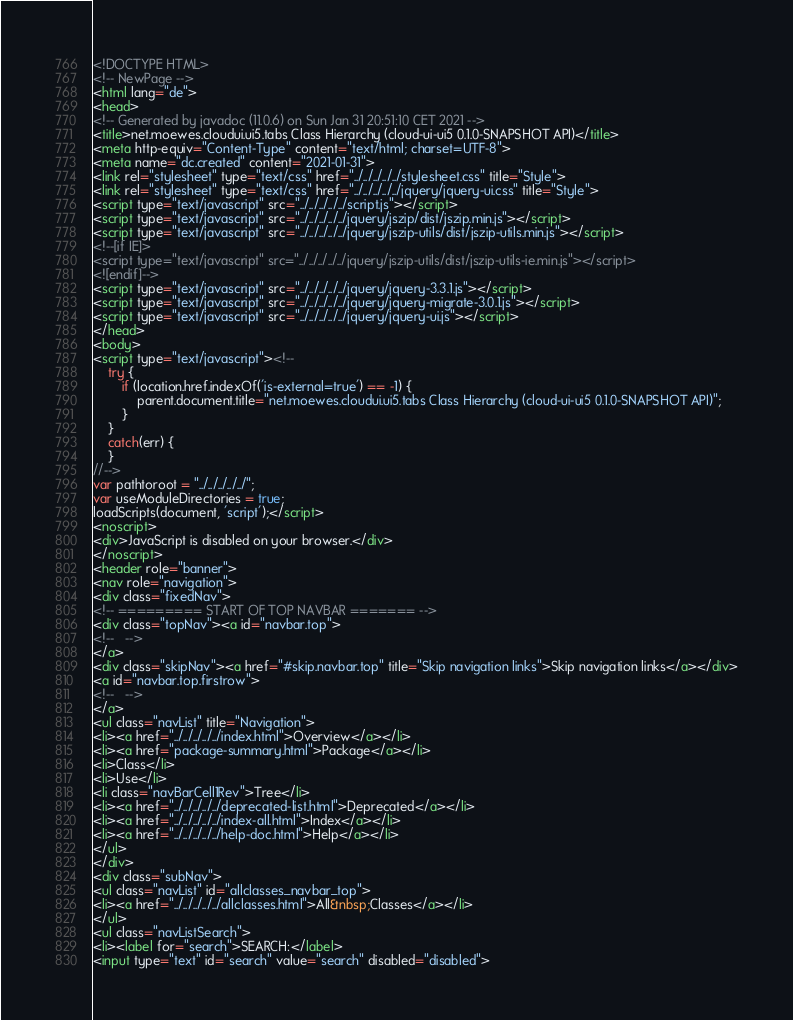<code> <loc_0><loc_0><loc_500><loc_500><_HTML_><!DOCTYPE HTML>
<!-- NewPage -->
<html lang="de">
<head>
<!-- Generated by javadoc (11.0.6) on Sun Jan 31 20:51:10 CET 2021 -->
<title>net.moewes.cloudui.ui5.tabs Class Hierarchy (cloud-ui-ui5 0.1.0-SNAPSHOT API)</title>
<meta http-equiv="Content-Type" content="text/html; charset=UTF-8">
<meta name="dc.created" content="2021-01-31">
<link rel="stylesheet" type="text/css" href="../../../../../stylesheet.css" title="Style">
<link rel="stylesheet" type="text/css" href="../../../../../jquery/jquery-ui.css" title="Style">
<script type="text/javascript" src="../../../../../script.js"></script>
<script type="text/javascript" src="../../../../../jquery/jszip/dist/jszip.min.js"></script>
<script type="text/javascript" src="../../../../../jquery/jszip-utils/dist/jszip-utils.min.js"></script>
<!--[if IE]>
<script type="text/javascript" src="../../../../../jquery/jszip-utils/dist/jszip-utils-ie.min.js"></script>
<![endif]-->
<script type="text/javascript" src="../../../../../jquery/jquery-3.3.1.js"></script>
<script type="text/javascript" src="../../../../../jquery/jquery-migrate-3.0.1.js"></script>
<script type="text/javascript" src="../../../../../jquery/jquery-ui.js"></script>
</head>
<body>
<script type="text/javascript"><!--
    try {
        if (location.href.indexOf('is-external=true') == -1) {
            parent.document.title="net.moewes.cloudui.ui5.tabs Class Hierarchy (cloud-ui-ui5 0.1.0-SNAPSHOT API)";
        }
    }
    catch(err) {
    }
//-->
var pathtoroot = "../../../../../";
var useModuleDirectories = true;
loadScripts(document, 'script');</script>
<noscript>
<div>JavaScript is disabled on your browser.</div>
</noscript>
<header role="banner">
<nav role="navigation">
<div class="fixedNav">
<!-- ========= START OF TOP NAVBAR ======= -->
<div class="topNav"><a id="navbar.top">
<!--   -->
</a>
<div class="skipNav"><a href="#skip.navbar.top" title="Skip navigation links">Skip navigation links</a></div>
<a id="navbar.top.firstrow">
<!--   -->
</a>
<ul class="navList" title="Navigation">
<li><a href="../../../../../index.html">Overview</a></li>
<li><a href="package-summary.html">Package</a></li>
<li>Class</li>
<li>Use</li>
<li class="navBarCell1Rev">Tree</li>
<li><a href="../../../../../deprecated-list.html">Deprecated</a></li>
<li><a href="../../../../../index-all.html">Index</a></li>
<li><a href="../../../../../help-doc.html">Help</a></li>
</ul>
</div>
<div class="subNav">
<ul class="navList" id="allclasses_navbar_top">
<li><a href="../../../../../allclasses.html">All&nbsp;Classes</a></li>
</ul>
<ul class="navListSearch">
<li><label for="search">SEARCH:</label>
<input type="text" id="search" value="search" disabled="disabled"></code> 